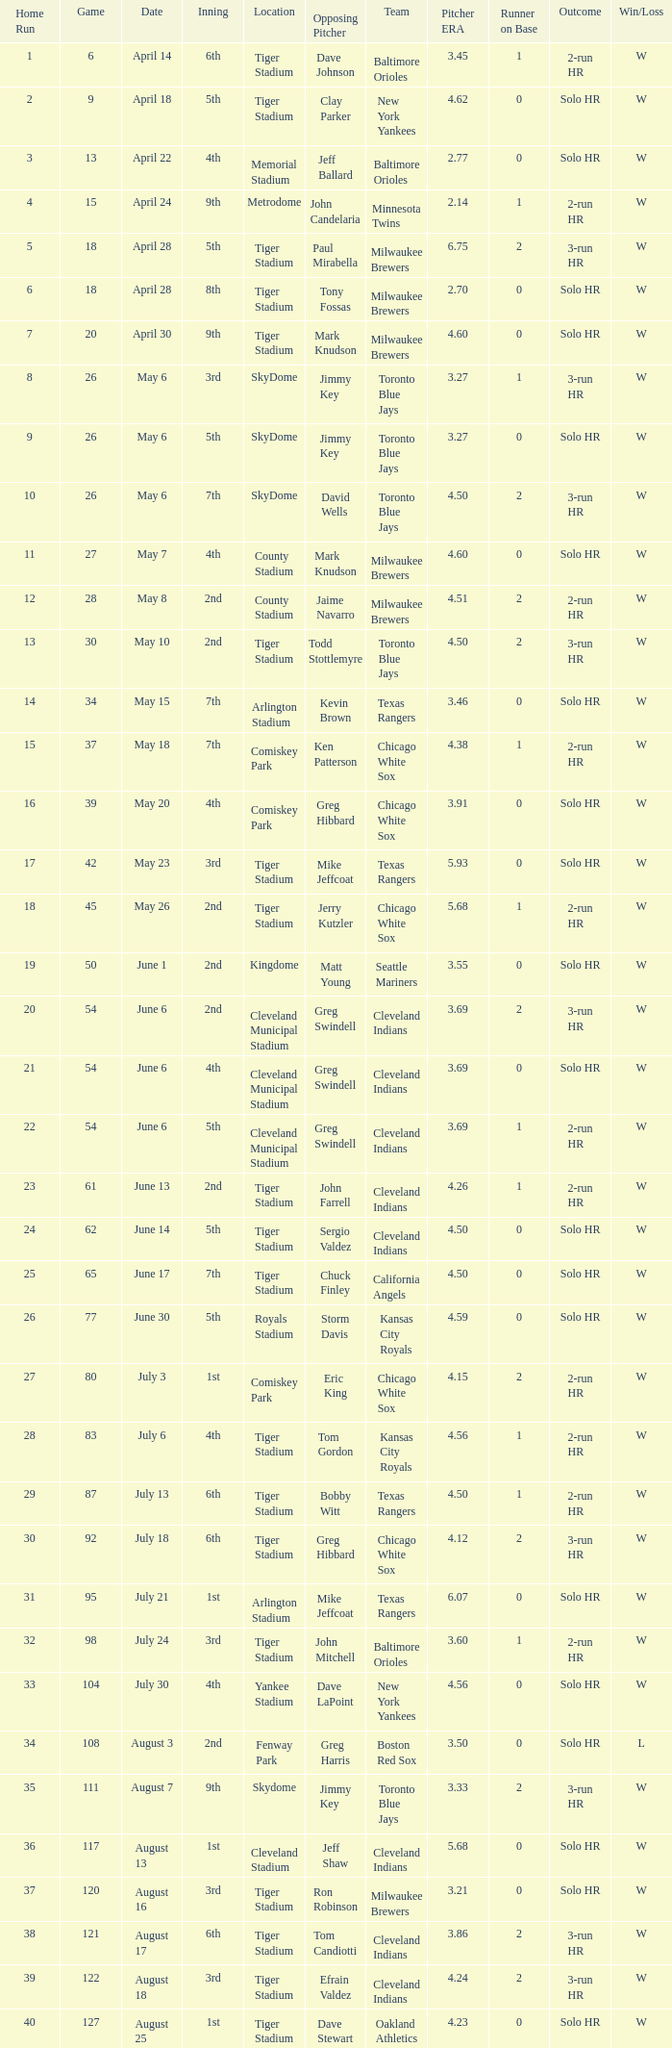I'm looking to parse the entire table for insights. Could you assist me with that? {'header': ['Home Run', 'Game', 'Date', 'Inning', 'Location', 'Opposing Pitcher', 'Team', 'Pitcher ERA', 'Runner on Base', 'Outcome', 'Win/Loss'], 'rows': [['1', '6', 'April 14', '6th', 'Tiger Stadium', 'Dave Johnson', 'Baltimore Orioles', '3.45', '1', '2-run HR', 'W'], ['2', '9', 'April 18', '5th', 'Tiger Stadium', 'Clay Parker', 'New York Yankees', '4.62', '0', 'Solo HR', 'W'], ['3', '13', 'April 22', '4th', 'Memorial Stadium', 'Jeff Ballard', 'Baltimore Orioles', '2.77', '0', 'Solo HR', 'W'], ['4', '15', 'April 24', '9th', 'Metrodome', 'John Candelaria', 'Minnesota Twins', '2.14', '1', '2-run HR', 'W'], ['5', '18', 'April 28', '5th', 'Tiger Stadium', 'Paul Mirabella', 'Milwaukee Brewers', '6.75', '2', '3-run HR', 'W'], ['6', '18', 'April 28', '8th', 'Tiger Stadium', 'Tony Fossas', 'Milwaukee Brewers', '2.70', '0', 'Solo HR', 'W'], ['7', '20', 'April 30', '9th', 'Tiger Stadium', 'Mark Knudson', 'Milwaukee Brewers', '4.60', '0', 'Solo HR', 'W'], ['8', '26', 'May 6', '3rd', 'SkyDome', 'Jimmy Key', 'Toronto Blue Jays', '3.27', '1', '3-run HR', 'W'], ['9', '26', 'May 6', '5th', 'SkyDome', 'Jimmy Key', 'Toronto Blue Jays', '3.27', '0', 'Solo HR', 'W'], ['10', '26', 'May 6', '7th', 'SkyDome', 'David Wells', 'Toronto Blue Jays', '4.50', '2', '3-run HR', 'W'], ['11', '27', 'May 7', '4th', 'County Stadium', 'Mark Knudson', 'Milwaukee Brewers', '4.60', '0', 'Solo HR', 'W'], ['12', '28', 'May 8', '2nd', 'County Stadium', 'Jaime Navarro', 'Milwaukee Brewers', '4.51', '2', '2-run HR', 'W'], ['13', '30', 'May 10', '2nd', 'Tiger Stadium', 'Todd Stottlemyre', 'Toronto Blue Jays', '4.50', '2', '3-run HR', 'W'], ['14', '34', 'May 15', '7th', 'Arlington Stadium', 'Kevin Brown', 'Texas Rangers', '3.46', '0', 'Solo HR', 'W'], ['15', '37', 'May 18', '7th', 'Comiskey Park', 'Ken Patterson', 'Chicago White Sox', '4.38', '1', '2-run HR', 'W'], ['16', '39', 'May 20', '4th', 'Comiskey Park', 'Greg Hibbard', 'Chicago White Sox', '3.91', '0', 'Solo HR', 'W'], ['17', '42', 'May 23', '3rd', 'Tiger Stadium', 'Mike Jeffcoat', 'Texas Rangers', '5.93', '0', 'Solo HR', 'W'], ['18', '45', 'May 26', '2nd', 'Tiger Stadium', 'Jerry Kutzler', 'Chicago White Sox', '5.68', '1', '2-run HR', 'W'], ['19', '50', 'June 1', '2nd', 'Kingdome', 'Matt Young', 'Seattle Mariners', '3.55', '0', 'Solo HR', 'W'], ['20', '54', 'June 6', '2nd', 'Cleveland Municipal Stadium', 'Greg Swindell', 'Cleveland Indians', '3.69', '2', '3-run HR', 'W'], ['21', '54', 'June 6', '4th', 'Cleveland Municipal Stadium', 'Greg Swindell', 'Cleveland Indians', '3.69', '0', 'Solo HR', 'W'], ['22', '54', 'June 6', '5th', 'Cleveland Municipal Stadium', 'Greg Swindell', 'Cleveland Indians', '3.69', '1', '2-run HR', 'W'], ['23', '61', 'June 13', '2nd', 'Tiger Stadium', 'John Farrell', 'Cleveland Indians', '4.26', '1', '2-run HR', 'W'], ['24', '62', 'June 14', '5th', 'Tiger Stadium', 'Sergio Valdez', 'Cleveland Indians', '4.50', '0', 'Solo HR', 'W'], ['25', '65', 'June 17', '7th', 'Tiger Stadium', 'Chuck Finley', 'California Angels', '4.50', '0', 'Solo HR', 'W'], ['26', '77', 'June 30', '5th', 'Royals Stadium', 'Storm Davis', 'Kansas City Royals', '4.59', '0', 'Solo HR', 'W'], ['27', '80', 'July 3', '1st', 'Comiskey Park', 'Eric King', 'Chicago White Sox', '4.15', '2', '2-run HR', 'W'], ['28', '83', 'July 6', '4th', 'Tiger Stadium', 'Tom Gordon', 'Kansas City Royals', '4.56', '1', '2-run HR', 'W'], ['29', '87', 'July 13', '6th', 'Tiger Stadium', 'Bobby Witt', 'Texas Rangers', '4.50', '1', '2-run HR', 'W'], ['30', '92', 'July 18', '6th', 'Tiger Stadium', 'Greg Hibbard', 'Chicago White Sox', '4.12', '2', '3-run HR', 'W'], ['31', '95', 'July 21', '1st', 'Arlington Stadium', 'Mike Jeffcoat', 'Texas Rangers', '6.07', '0', 'Solo HR', 'W'], ['32', '98', 'July 24', '3rd', 'Tiger Stadium', 'John Mitchell', 'Baltimore Orioles', '3.60', '1', '2-run HR', 'W'], ['33', '104', 'July 30', '4th', 'Yankee Stadium', 'Dave LaPoint', 'New York Yankees', '4.56', '0', 'Solo HR', 'W'], ['34', '108', 'August 3', '2nd', 'Fenway Park', 'Greg Harris', 'Boston Red Sox', '3.50', '0', 'Solo HR', 'L'], ['35', '111', 'August 7', '9th', 'Skydome', 'Jimmy Key', 'Toronto Blue Jays', '3.33', '2', '3-run HR', 'W'], ['36', '117', 'August 13', '1st', 'Cleveland Stadium', 'Jeff Shaw', 'Cleveland Indians', '5.68', '0', 'Solo HR', 'W'], ['37', '120', 'August 16', '3rd', 'Tiger Stadium', 'Ron Robinson', 'Milwaukee Brewers', '3.21', '0', 'Solo HR', 'W'], ['38', '121', 'August 17', '6th', 'Tiger Stadium', 'Tom Candiotti', 'Cleveland Indians', '3.86', '2', '3-run HR', 'W'], ['39', '122', 'August 18', '3rd', 'Tiger Stadium', 'Efrain Valdez', 'Cleveland Indians', '4.24', '2', '3-run HR', 'W'], ['40', '127', 'August 25', '1st', 'Tiger Stadium', 'Dave Stewart', 'Oakland Athletics', '4.23', '0', 'Solo HR', 'W'], ['41', '127', 'August 25', '4th', 'Tiger Stadium', 'Dave Stewart', 'Oakland Athletics', '4.23', '0', 'Solo HR', 'W'], ['42', '130', 'August 29', '8th', 'Kingdome', 'Matt Young', 'Seattle Mariners', '3.75', '1', '2-run HR', 'W'], ['43', '135', 'September 3', '6th', 'Tiger Stadium', 'Jimmy Key', 'Toronto Blue Jays', '3.39', '2', '3-run HR', 'W'], ['44', '137', 'September 5', '6th', 'Tiger Stadium', 'David Wells', 'Toronto Blue Jays', '4.09', '0', 'Solo HR', 'L'], ['45', '139', 'September 7', '6th', 'County Stadium', 'Ted Higuera', 'Milwaukee Brewers', '3.43', '1', '2-run HR', 'W'], ['46', '145', 'September 13', '9th', 'Tiger Stadium', 'Mike Witt', 'New York Yankees', '3.77', '1', '2-run HR', 'W'], ['47', '148', 'September 16', '5th', 'Tiger Stadium', 'Mark Leiter', 'New York Yankees', '4.07', '1', '2-run HR', 'W'], ['48', '153', 'September 23', '2nd', 'Oakland Coliseum', 'Mike Moore', 'Oakland Athletics', '4.41', '1', '2-run HR', 'L'], ['49', '156', 'September 27', '8th', 'Tiger Stadium', 'Dennis Lamp', 'Boston Red Sox', '5.00', '2', '3-run HR', 'W'], ['50', '162', 'October 3', '4th', 'Yankee Stadium', 'Steve Adkins', 'New York Yankees', '4.15', '0', 'Solo HR', 'W'], ['51', '162', 'October 3', '8th', 'Yankee Stadium', 'Alan Mills', 'New York Yankees', '5.03', '1', '2-run HR', 'W']]} When Efrain Valdez was pitching, what was the highest home run? 39.0. 